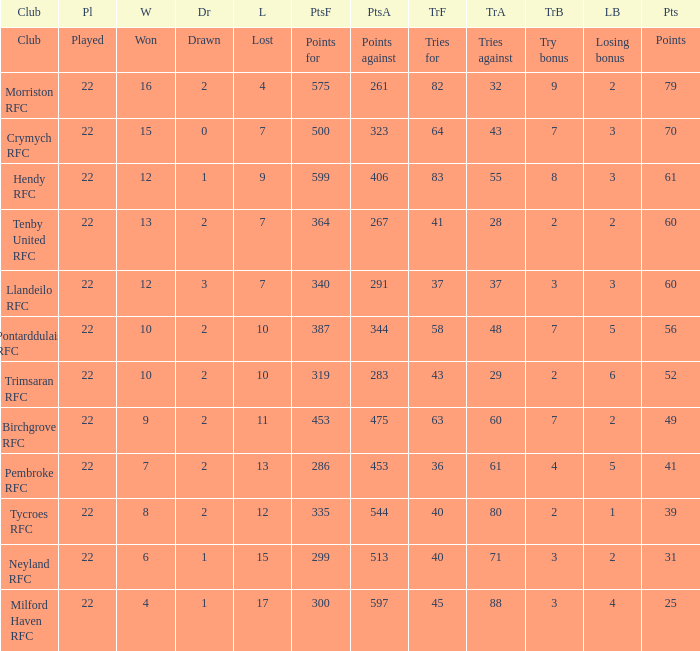 how many points against with tries for being 43 1.0. Would you mind parsing the complete table? {'header': ['Club', 'Pl', 'W', 'Dr', 'L', 'PtsF', 'PtsA', 'TrF', 'TrA', 'TrB', 'LB', 'Pts'], 'rows': [['Club', 'Played', 'Won', 'Drawn', 'Lost', 'Points for', 'Points against', 'Tries for', 'Tries against', 'Try bonus', 'Losing bonus', 'Points'], ['Morriston RFC', '22', '16', '2', '4', '575', '261', '82', '32', '9', '2', '79'], ['Crymych RFC', '22', '15', '0', '7', '500', '323', '64', '43', '7', '3', '70'], ['Hendy RFC', '22', '12', '1', '9', '599', '406', '83', '55', '8', '3', '61'], ['Tenby United RFC', '22', '13', '2', '7', '364', '267', '41', '28', '2', '2', '60'], ['Llandeilo RFC', '22', '12', '3', '7', '340', '291', '37', '37', '3', '3', '60'], ['Pontarddulais RFC', '22', '10', '2', '10', '387', '344', '58', '48', '7', '5', '56'], ['Trimsaran RFC', '22', '10', '2', '10', '319', '283', '43', '29', '2', '6', '52'], ['Birchgrove RFC', '22', '9', '2', '11', '453', '475', '63', '60', '7', '2', '49'], ['Pembroke RFC', '22', '7', '2', '13', '286', '453', '36', '61', '4', '5', '41'], ['Tycroes RFC', '22', '8', '2', '12', '335', '544', '40', '80', '2', '1', '39'], ['Neyland RFC', '22', '6', '1', '15', '299', '513', '40', '71', '3', '2', '31'], ['Milford Haven RFC', '22', '4', '1', '17', '300', '597', '45', '88', '3', '4', '25']]} 